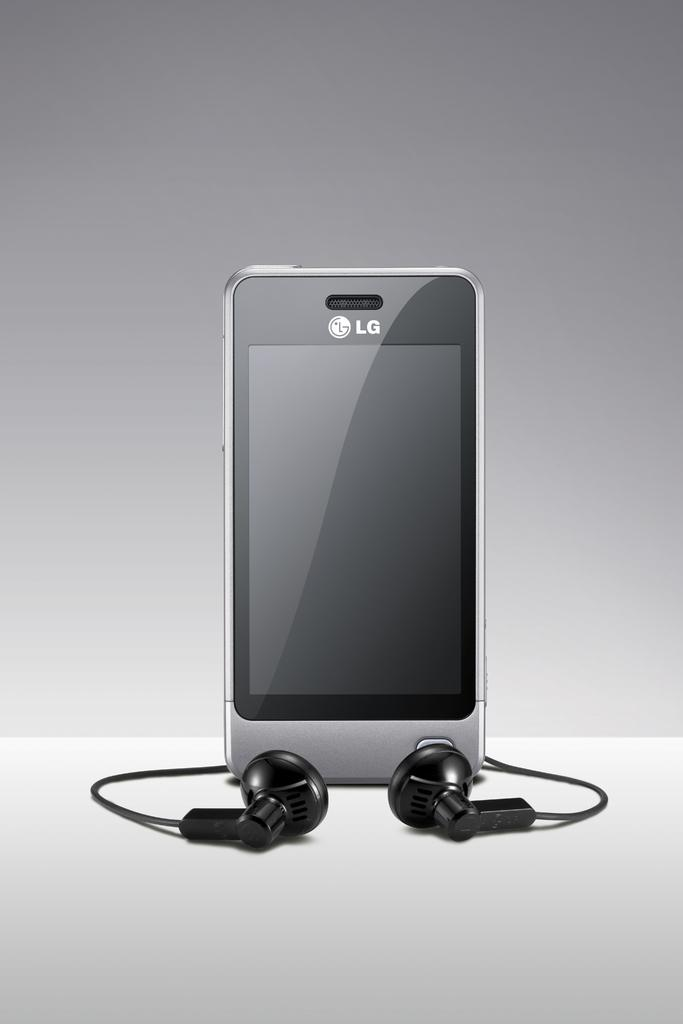What is the main object in the image? There is a mobile in the image. What type of accessory is also visible in the image? There are black color earphones in the image. What is the color of the surface on which the objects are placed? The objects are on a white color surface. What color is the background of the image? The background of the image is grey in color. How many goldfish are swimming in the image? There are no goldfish present in the image. What type of tax is being discussed in the image? There is no discussion of tax in the image. 